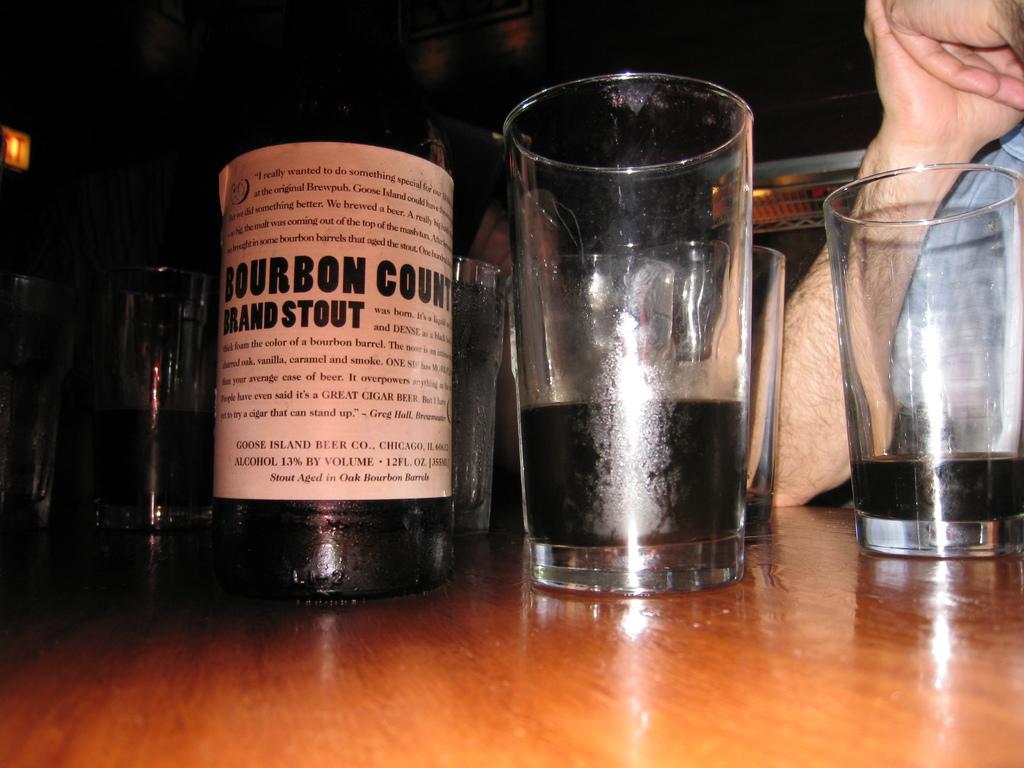What company made the beer?
Offer a very short reply. Bourbon county. 